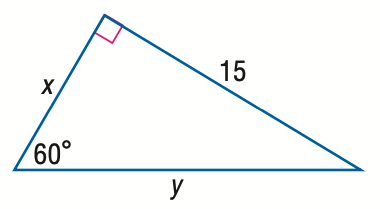Question: Find x.
Choices:
A. 5 \sqrt { 3 }
B. 15
C. 15 \sqrt { 3 }
D. 30
Answer with the letter. Answer: A 